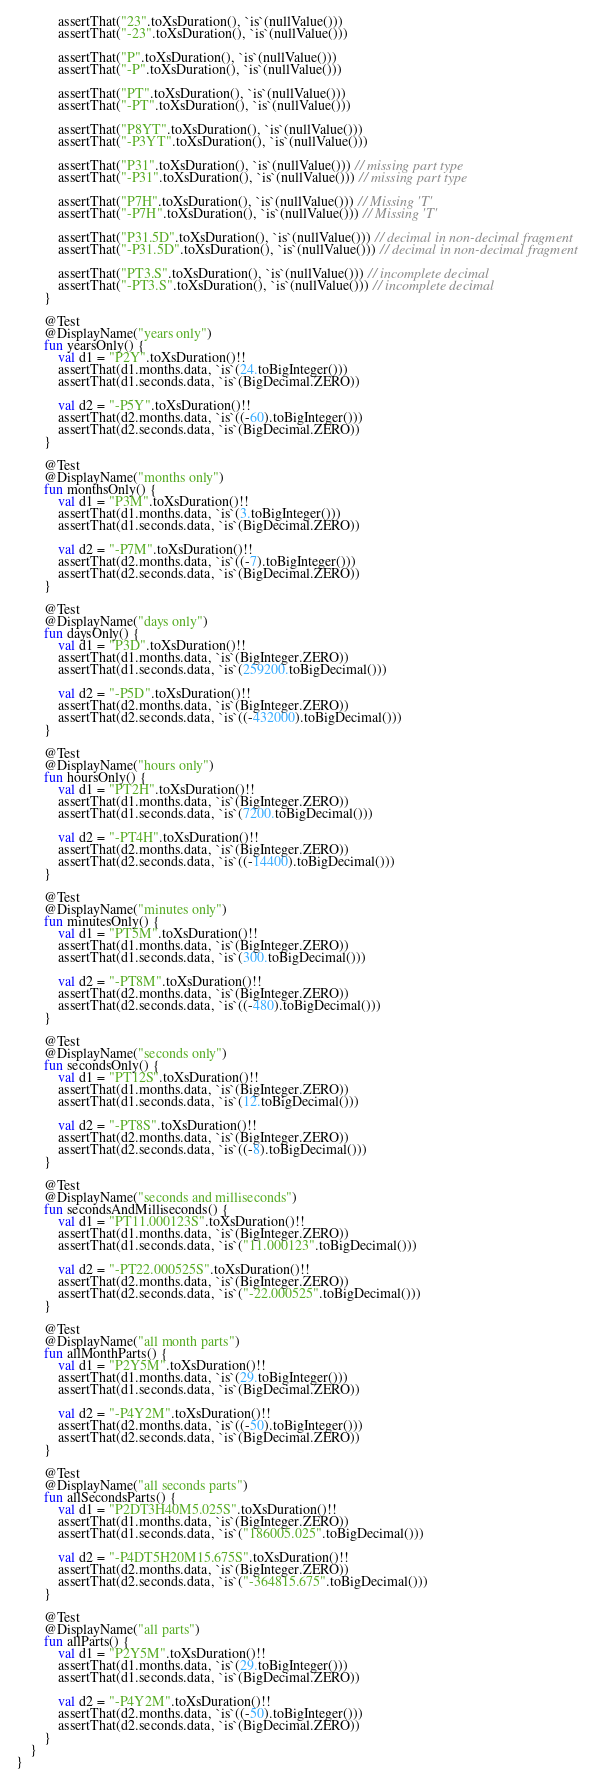Convert code to text. <code><loc_0><loc_0><loc_500><loc_500><_Kotlin_>            assertThat("23".toXsDuration(), `is`(nullValue()))
            assertThat("-23".toXsDuration(), `is`(nullValue()))

            assertThat("P".toXsDuration(), `is`(nullValue()))
            assertThat("-P".toXsDuration(), `is`(nullValue()))

            assertThat("PT".toXsDuration(), `is`(nullValue()))
            assertThat("-PT".toXsDuration(), `is`(nullValue()))

            assertThat("P8YT".toXsDuration(), `is`(nullValue()))
            assertThat("-P3YT".toXsDuration(), `is`(nullValue()))

            assertThat("P31".toXsDuration(), `is`(nullValue())) // missing part type
            assertThat("-P31".toXsDuration(), `is`(nullValue())) // missing part type

            assertThat("P7H".toXsDuration(), `is`(nullValue())) // Missing 'T'
            assertThat("-P7H".toXsDuration(), `is`(nullValue())) // Missing 'T'

            assertThat("P31.5D".toXsDuration(), `is`(nullValue())) // decimal in non-decimal fragment
            assertThat("-P31.5D".toXsDuration(), `is`(nullValue())) // decimal in non-decimal fragment

            assertThat("PT3.S".toXsDuration(), `is`(nullValue())) // incomplete decimal
            assertThat("-PT3.S".toXsDuration(), `is`(nullValue())) // incomplete decimal
        }

        @Test
        @DisplayName("years only")
        fun yearsOnly() {
            val d1 = "P2Y".toXsDuration()!!
            assertThat(d1.months.data, `is`(24.toBigInteger()))
            assertThat(d1.seconds.data, `is`(BigDecimal.ZERO))

            val d2 = "-P5Y".toXsDuration()!!
            assertThat(d2.months.data, `is`((-60).toBigInteger()))
            assertThat(d2.seconds.data, `is`(BigDecimal.ZERO))
        }

        @Test
        @DisplayName("months only")
        fun monthsOnly() {
            val d1 = "P3M".toXsDuration()!!
            assertThat(d1.months.data, `is`(3.toBigInteger()))
            assertThat(d1.seconds.data, `is`(BigDecimal.ZERO))

            val d2 = "-P7M".toXsDuration()!!
            assertThat(d2.months.data, `is`((-7).toBigInteger()))
            assertThat(d2.seconds.data, `is`(BigDecimal.ZERO))
        }

        @Test
        @DisplayName("days only")
        fun daysOnly() {
            val d1 = "P3D".toXsDuration()!!
            assertThat(d1.months.data, `is`(BigInteger.ZERO))
            assertThat(d1.seconds.data, `is`(259200.toBigDecimal()))

            val d2 = "-P5D".toXsDuration()!!
            assertThat(d2.months.data, `is`(BigInteger.ZERO))
            assertThat(d2.seconds.data, `is`((-432000).toBigDecimal()))
        }

        @Test
        @DisplayName("hours only")
        fun hoursOnly() {
            val d1 = "PT2H".toXsDuration()!!
            assertThat(d1.months.data, `is`(BigInteger.ZERO))
            assertThat(d1.seconds.data, `is`(7200.toBigDecimal()))

            val d2 = "-PT4H".toXsDuration()!!
            assertThat(d2.months.data, `is`(BigInteger.ZERO))
            assertThat(d2.seconds.data, `is`((-14400).toBigDecimal()))
        }

        @Test
        @DisplayName("minutes only")
        fun minutesOnly() {
            val d1 = "PT5M".toXsDuration()!!
            assertThat(d1.months.data, `is`(BigInteger.ZERO))
            assertThat(d1.seconds.data, `is`(300.toBigDecimal()))

            val d2 = "-PT8M".toXsDuration()!!
            assertThat(d2.months.data, `is`(BigInteger.ZERO))
            assertThat(d2.seconds.data, `is`((-480).toBigDecimal()))
        }

        @Test
        @DisplayName("seconds only")
        fun secondsOnly() {
            val d1 = "PT12S".toXsDuration()!!
            assertThat(d1.months.data, `is`(BigInteger.ZERO))
            assertThat(d1.seconds.data, `is`(12.toBigDecimal()))

            val d2 = "-PT8S".toXsDuration()!!
            assertThat(d2.months.data, `is`(BigInteger.ZERO))
            assertThat(d2.seconds.data, `is`((-8).toBigDecimal()))
        }

        @Test
        @DisplayName("seconds and milliseconds")
        fun secondsAndMilliseconds() {
            val d1 = "PT11.000123S".toXsDuration()!!
            assertThat(d1.months.data, `is`(BigInteger.ZERO))
            assertThat(d1.seconds.data, `is`("11.000123".toBigDecimal()))

            val d2 = "-PT22.000525S".toXsDuration()!!
            assertThat(d2.months.data, `is`(BigInteger.ZERO))
            assertThat(d2.seconds.data, `is`("-22.000525".toBigDecimal()))
        }

        @Test
        @DisplayName("all month parts")
        fun allMonthParts() {
            val d1 = "P2Y5M".toXsDuration()!!
            assertThat(d1.months.data, `is`(29.toBigInteger()))
            assertThat(d1.seconds.data, `is`(BigDecimal.ZERO))

            val d2 = "-P4Y2M".toXsDuration()!!
            assertThat(d2.months.data, `is`((-50).toBigInteger()))
            assertThat(d2.seconds.data, `is`(BigDecimal.ZERO))
        }

        @Test
        @DisplayName("all seconds parts")
        fun allSecondsParts() {
            val d1 = "P2DT3H40M5.025S".toXsDuration()!!
            assertThat(d1.months.data, `is`(BigInteger.ZERO))
            assertThat(d1.seconds.data, `is`("186005.025".toBigDecimal()))

            val d2 = "-P4DT5H20M15.675S".toXsDuration()!!
            assertThat(d2.months.data, `is`(BigInteger.ZERO))
            assertThat(d2.seconds.data, `is`("-364815.675".toBigDecimal()))
        }

        @Test
        @DisplayName("all parts")
        fun allParts() {
            val d1 = "P2Y5M".toXsDuration()!!
            assertThat(d1.months.data, `is`(29.toBigInteger()))
            assertThat(d1.seconds.data, `is`(BigDecimal.ZERO))

            val d2 = "-P4Y2M".toXsDuration()!!
            assertThat(d2.months.data, `is`((-50).toBigInteger()))
            assertThat(d2.seconds.data, `is`(BigDecimal.ZERO))
        }
    }
}
</code> 